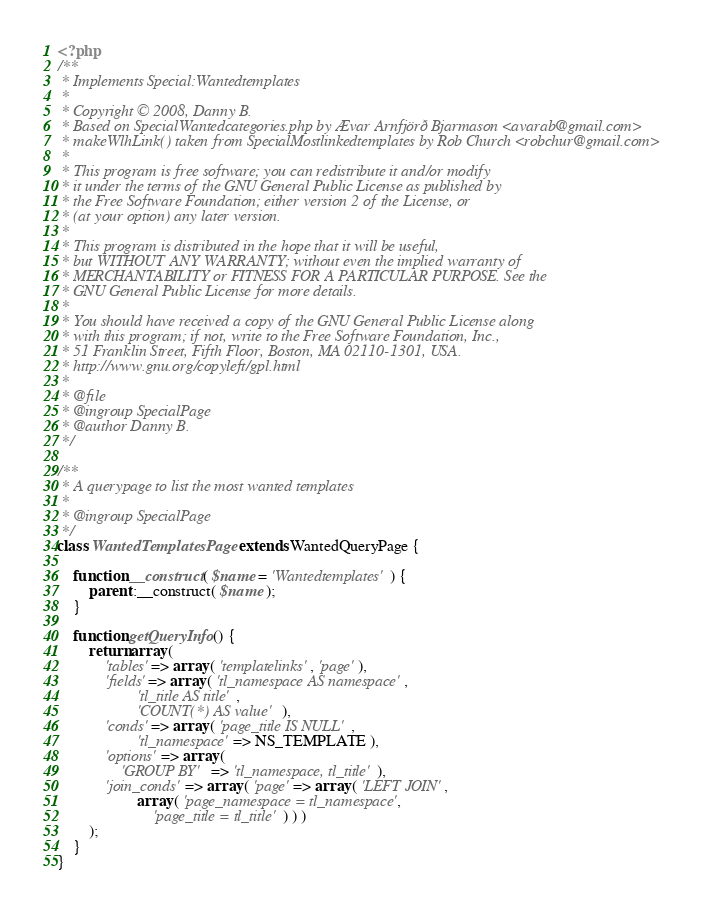<code> <loc_0><loc_0><loc_500><loc_500><_PHP_><?php
/**
 * Implements Special:Wantedtemplates
 *
 * Copyright © 2008, Danny B.
 * Based on SpecialWantedcategories.php by Ævar Arnfjörð Bjarmason <avarab@gmail.com>
 * makeWlhLink() taken from SpecialMostlinkedtemplates by Rob Church <robchur@gmail.com>
 *
 * This program is free software; you can redistribute it and/or modify
 * it under the terms of the GNU General Public License as published by
 * the Free Software Foundation; either version 2 of the License, or
 * (at your option) any later version.
 *
 * This program is distributed in the hope that it will be useful,
 * but WITHOUT ANY WARRANTY; without even the implied warranty of
 * MERCHANTABILITY or FITNESS FOR A PARTICULAR PURPOSE. See the
 * GNU General Public License for more details.
 *
 * You should have received a copy of the GNU General Public License along
 * with this program; if not, write to the Free Software Foundation, Inc.,
 * 51 Franklin Street, Fifth Floor, Boston, MA 02110-1301, USA.
 * http://www.gnu.org/copyleft/gpl.html
 *
 * @file
 * @ingroup SpecialPage
 * @author Danny B.
 */

/**
 * A querypage to list the most wanted templates
 *
 * @ingroup SpecialPage
 */
class WantedTemplatesPage extends WantedQueryPage {

	function __construct( $name = 'Wantedtemplates' ) {
		parent::__construct( $name );
	}

	function getQueryInfo() {
		return array (
			'tables' => array ( 'templatelinks', 'page' ),
			'fields' => array ( 'tl_namespace AS namespace',
					'tl_title AS title',
					'COUNT(*) AS value' ),
			'conds' => array ( 'page_title IS NULL',
					'tl_namespace' => NS_TEMPLATE ),
			'options' => array (
				'GROUP BY' => 'tl_namespace, tl_title' ),
			'join_conds' => array ( 'page' => array ( 'LEFT JOIN',
					array ( 'page_namespace = tl_namespace',
						'page_title = tl_title' ) ) )
		);
	}
}
</code> 